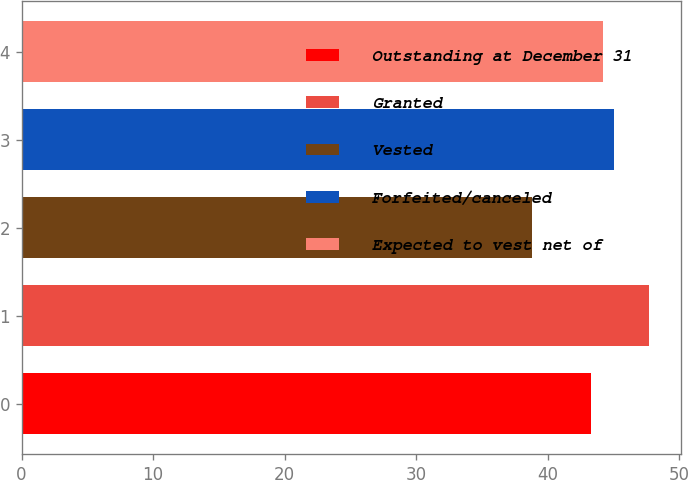<chart> <loc_0><loc_0><loc_500><loc_500><bar_chart><fcel>Outstanding at December 31<fcel>Granted<fcel>Vested<fcel>Forfeited/canceled<fcel>Expected to vest net of<nl><fcel>43.27<fcel>47.71<fcel>38.78<fcel>45.05<fcel>44.16<nl></chart> 